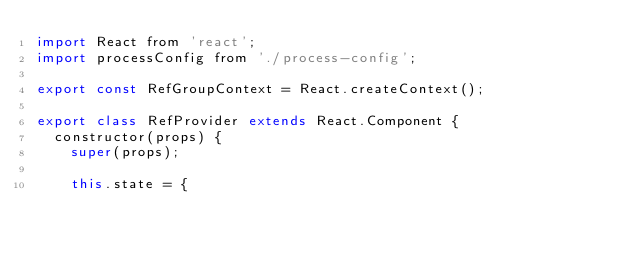<code> <loc_0><loc_0><loc_500><loc_500><_JavaScript_>import React from 'react';
import processConfig from './process-config';

export const RefGroupContext = React.createContext();

export class RefProvider extends React.Component {
  constructor(props) {
    super(props);

    this.state = {</code> 